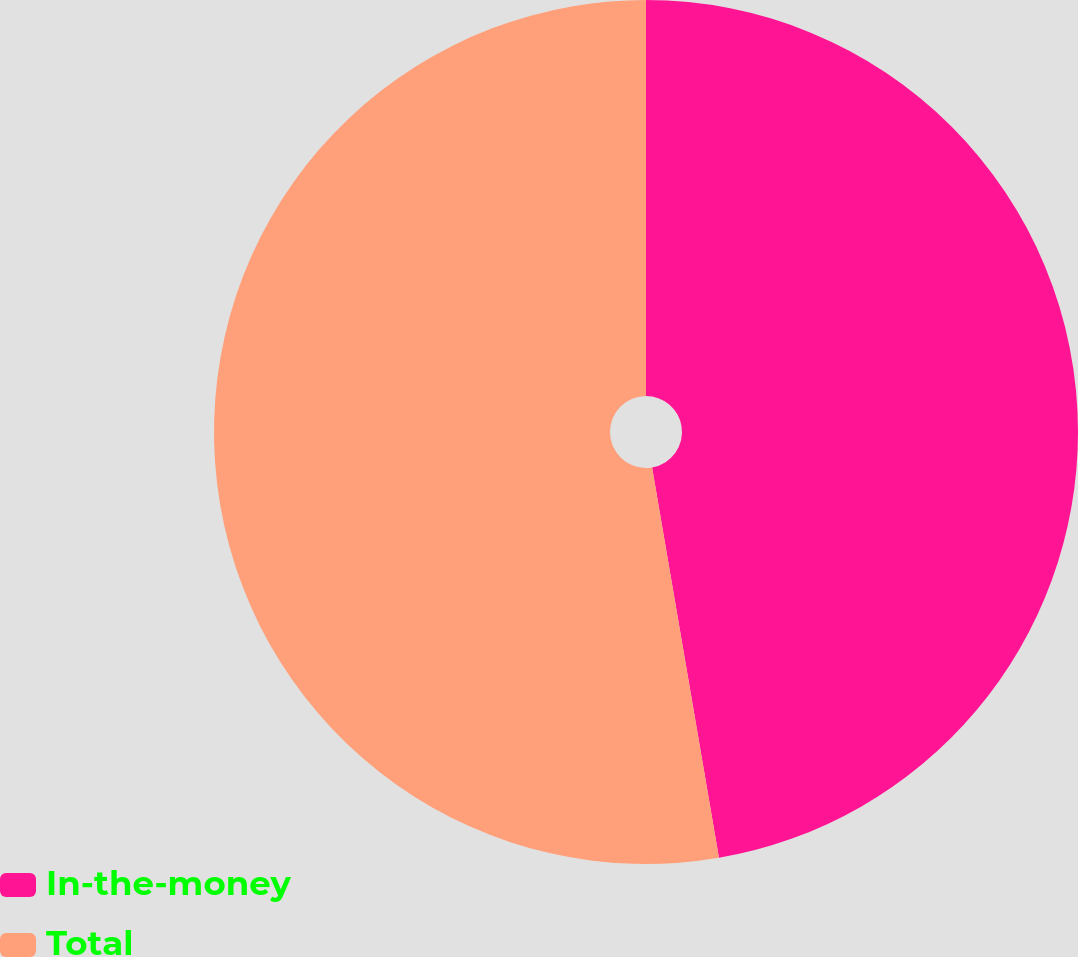Convert chart to OTSL. <chart><loc_0><loc_0><loc_500><loc_500><pie_chart><fcel>In-the-money<fcel>Total<nl><fcel>47.3%<fcel>52.7%<nl></chart> 